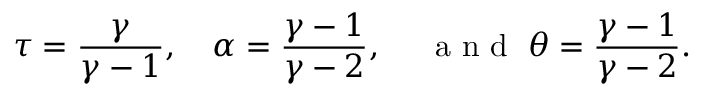<formula> <loc_0><loc_0><loc_500><loc_500>\tau = \frac { \gamma } { \gamma - 1 } , \alpha = \frac { \gamma - 1 } { \gamma - 2 } , \, a n d \, \theta = \frac { \gamma - 1 } { \gamma - 2 } .</formula> 